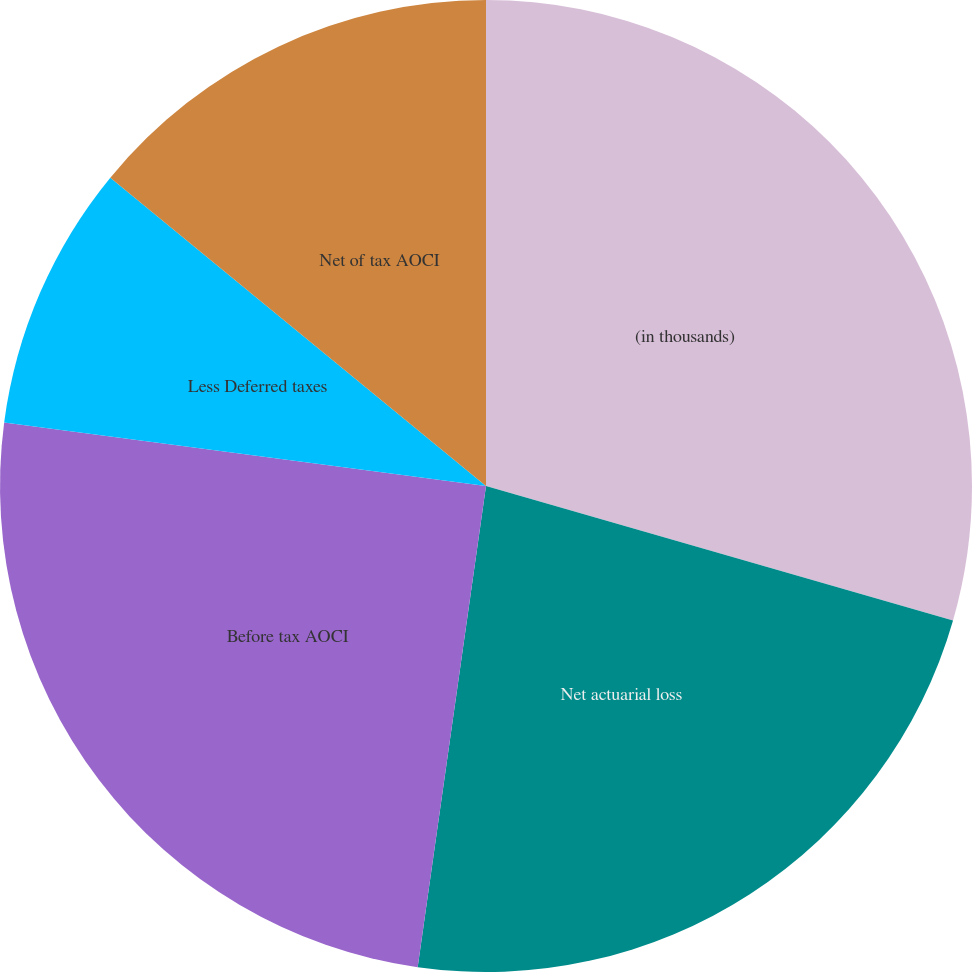Convert chart. <chart><loc_0><loc_0><loc_500><loc_500><pie_chart><fcel>(in thousands)<fcel>Net actuarial loss<fcel>Before tax AOCI<fcel>Less Deferred taxes<fcel>Net of tax AOCI<nl><fcel>29.46%<fcel>22.78%<fcel>24.84%<fcel>8.85%<fcel>14.06%<nl></chart> 